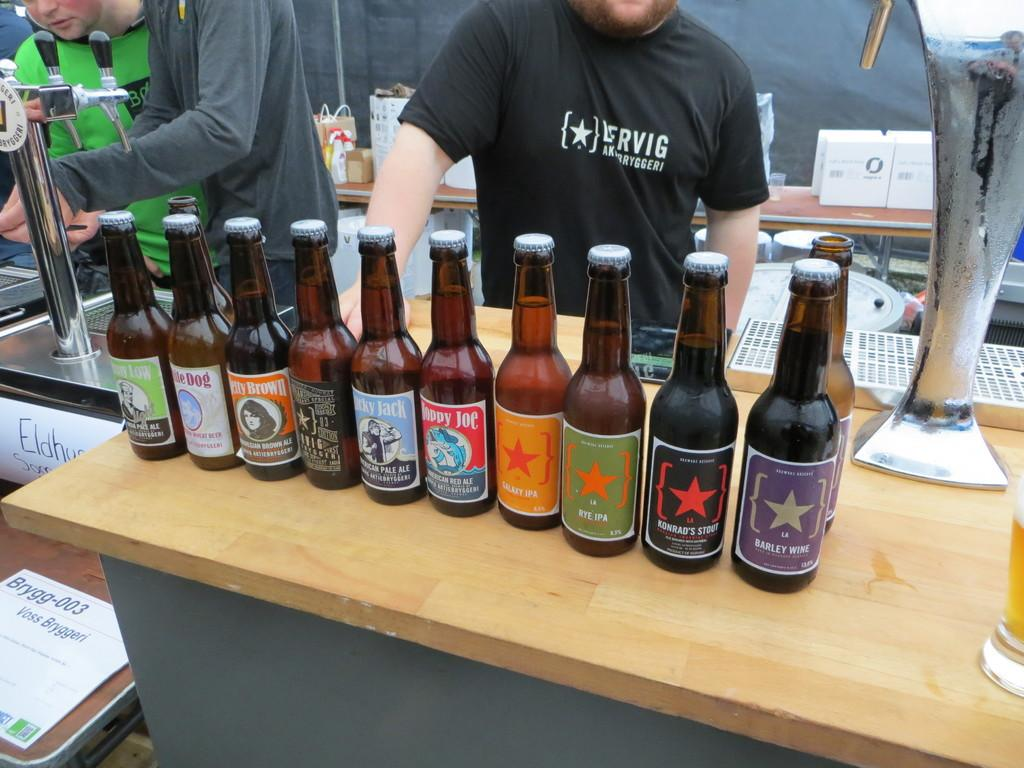<image>
Create a compact narrative representing the image presented. A bottle of barley wine is on the end of a line of bottles. 